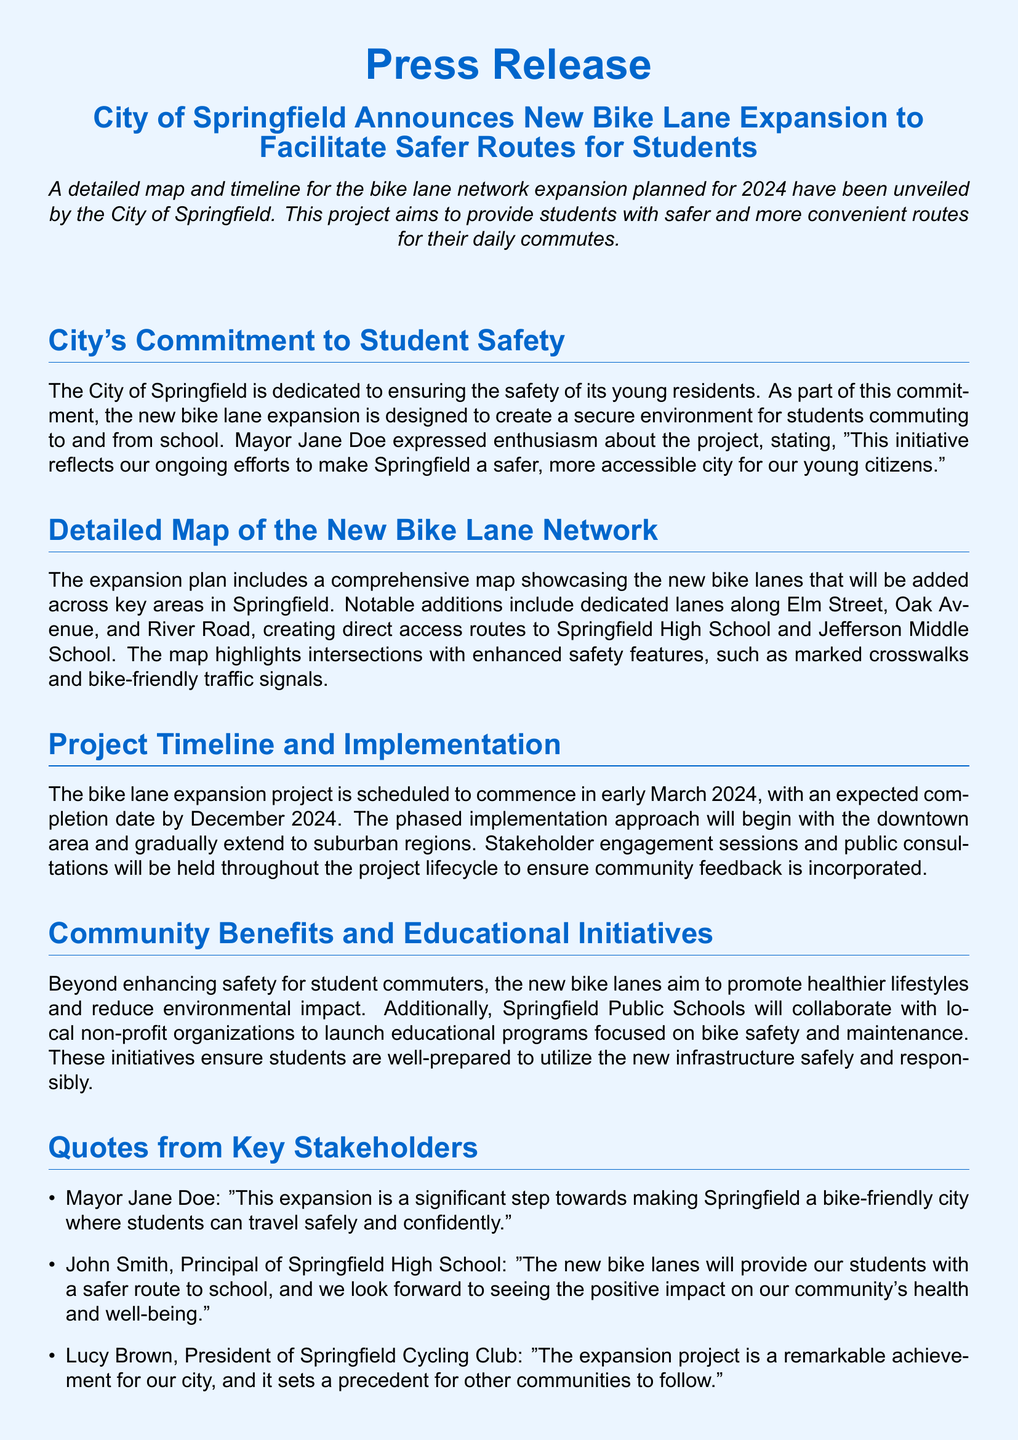What is the title of the press release? The title of the press release is prominently stated at the top of the document.
Answer: City of Springfield Announces New Bike Lane Expansion to Facilitate Safer Routes for Students When is the project scheduled to commence? The document states the beginning date of the project in the project timeline section.
Answer: Early March 2024 Which streets will have new bike lanes? The detailed map section highlights specific streets that will feature bike lanes.
Answer: Elm Street, Oak Avenue, River Road Who is the Mayor of Springfield? The document includes a quote from the Mayor, indicating her role in the city.
Answer: Jane Doe What is the expected completion date for the project? The completion date is mentioned in the project timeline section of the document.
Answer: December 2024 What is the primary aim of the bike lane expansion? The document outlines the main goal of the project in the introductory paragraph.
Answer: Safer routes for students What organization will collaborate with schools for educational programs? The document specifies an entity that will work with the schools on educational initiatives.
Answer: Local non-profit organizations What type of sessions will be held during the project? The project outlines participant engagement activities in the implementation section.
Answer: Stakeholder engagement sessions and public consultations How does the City of Springfield regard the expansion? The quotes section reflects the sentiments from key stakeholders about the project.
Answer: A significant step towards making Springfield a bike-friendly city 